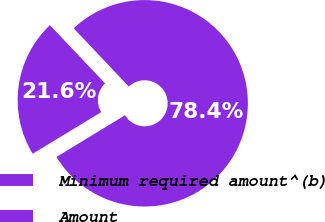Convert chart to OTSL. <chart><loc_0><loc_0><loc_500><loc_500><pie_chart><fcel>Minimum required amount^(b)<fcel>Amount<nl><fcel>21.64%<fcel>78.36%<nl></chart> 